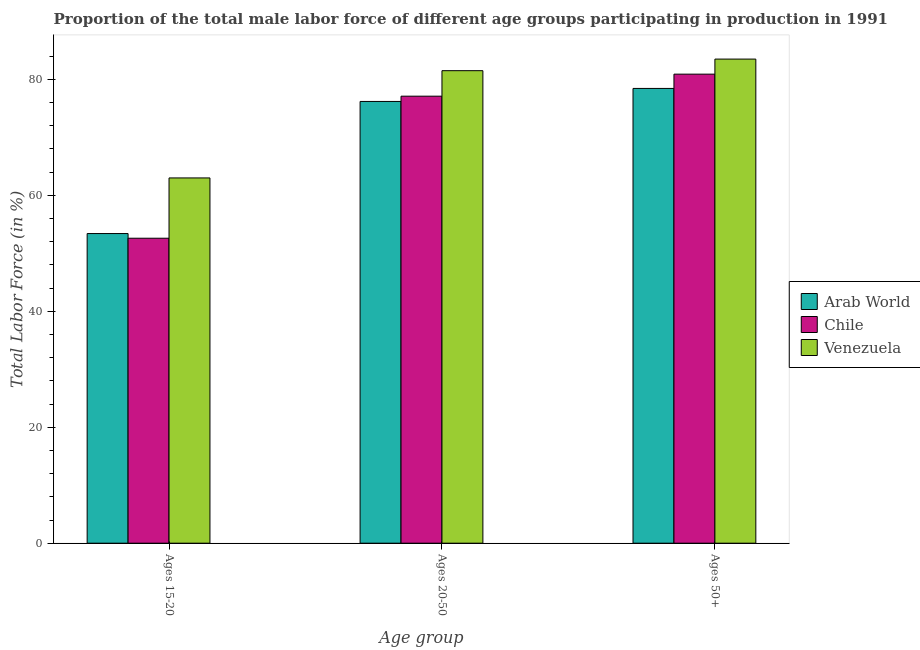How many different coloured bars are there?
Give a very brief answer. 3. What is the label of the 2nd group of bars from the left?
Offer a very short reply. Ages 20-50. What is the percentage of male labor force within the age group 15-20 in Chile?
Offer a very short reply. 52.6. Across all countries, what is the minimum percentage of male labor force within the age group 20-50?
Provide a succinct answer. 76.19. In which country was the percentage of male labor force within the age group 15-20 maximum?
Offer a terse response. Venezuela. In which country was the percentage of male labor force above age 50 minimum?
Give a very brief answer. Arab World. What is the total percentage of male labor force within the age group 20-50 in the graph?
Keep it short and to the point. 234.79. What is the difference between the percentage of male labor force above age 50 in Chile and that in Arab World?
Offer a very short reply. 2.46. What is the difference between the percentage of male labor force within the age group 20-50 in Venezuela and the percentage of male labor force within the age group 15-20 in Chile?
Provide a succinct answer. 28.9. What is the average percentage of male labor force within the age group 20-50 per country?
Offer a very short reply. 78.26. What is the difference between the percentage of male labor force within the age group 15-20 and percentage of male labor force above age 50 in Venezuela?
Offer a very short reply. -20.5. In how many countries, is the percentage of male labor force above age 50 greater than 24 %?
Ensure brevity in your answer.  3. What is the ratio of the percentage of male labor force within the age group 20-50 in Chile to that in Arab World?
Offer a terse response. 1.01. Is the difference between the percentage of male labor force above age 50 in Venezuela and Arab World greater than the difference between the percentage of male labor force within the age group 20-50 in Venezuela and Arab World?
Keep it short and to the point. No. What is the difference between the highest and the second highest percentage of male labor force within the age group 20-50?
Give a very brief answer. 4.4. What is the difference between the highest and the lowest percentage of male labor force within the age group 20-50?
Provide a short and direct response. 5.31. In how many countries, is the percentage of male labor force above age 50 greater than the average percentage of male labor force above age 50 taken over all countries?
Provide a short and direct response. 1. Is the sum of the percentage of male labor force within the age group 20-50 in Venezuela and Chile greater than the maximum percentage of male labor force within the age group 15-20 across all countries?
Your answer should be very brief. Yes. What does the 3rd bar from the right in Ages 20-50 represents?
Your response must be concise. Arab World. Is it the case that in every country, the sum of the percentage of male labor force within the age group 15-20 and percentage of male labor force within the age group 20-50 is greater than the percentage of male labor force above age 50?
Provide a succinct answer. Yes. Are all the bars in the graph horizontal?
Your answer should be compact. No. What is the difference between two consecutive major ticks on the Y-axis?
Give a very brief answer. 20. Does the graph contain any zero values?
Make the answer very short. No. What is the title of the graph?
Your response must be concise. Proportion of the total male labor force of different age groups participating in production in 1991. What is the label or title of the X-axis?
Offer a very short reply. Age group. What is the Total Labor Force (in %) in Arab World in Ages 15-20?
Offer a very short reply. 53.41. What is the Total Labor Force (in %) in Chile in Ages 15-20?
Your response must be concise. 52.6. What is the Total Labor Force (in %) in Arab World in Ages 20-50?
Provide a short and direct response. 76.19. What is the Total Labor Force (in %) in Chile in Ages 20-50?
Offer a very short reply. 77.1. What is the Total Labor Force (in %) of Venezuela in Ages 20-50?
Give a very brief answer. 81.5. What is the Total Labor Force (in %) of Arab World in Ages 50+?
Your answer should be very brief. 78.44. What is the Total Labor Force (in %) in Chile in Ages 50+?
Give a very brief answer. 80.9. What is the Total Labor Force (in %) of Venezuela in Ages 50+?
Offer a terse response. 83.5. Across all Age group, what is the maximum Total Labor Force (in %) of Arab World?
Provide a short and direct response. 78.44. Across all Age group, what is the maximum Total Labor Force (in %) of Chile?
Provide a succinct answer. 80.9. Across all Age group, what is the maximum Total Labor Force (in %) in Venezuela?
Offer a terse response. 83.5. Across all Age group, what is the minimum Total Labor Force (in %) of Arab World?
Provide a succinct answer. 53.41. Across all Age group, what is the minimum Total Labor Force (in %) in Chile?
Your answer should be very brief. 52.6. Across all Age group, what is the minimum Total Labor Force (in %) in Venezuela?
Your answer should be compact. 63. What is the total Total Labor Force (in %) of Arab World in the graph?
Give a very brief answer. 208.04. What is the total Total Labor Force (in %) in Chile in the graph?
Keep it short and to the point. 210.6. What is the total Total Labor Force (in %) of Venezuela in the graph?
Ensure brevity in your answer.  228. What is the difference between the Total Labor Force (in %) of Arab World in Ages 15-20 and that in Ages 20-50?
Make the answer very short. -22.78. What is the difference between the Total Labor Force (in %) in Chile in Ages 15-20 and that in Ages 20-50?
Your answer should be very brief. -24.5. What is the difference between the Total Labor Force (in %) of Venezuela in Ages 15-20 and that in Ages 20-50?
Provide a short and direct response. -18.5. What is the difference between the Total Labor Force (in %) in Arab World in Ages 15-20 and that in Ages 50+?
Ensure brevity in your answer.  -25.03. What is the difference between the Total Labor Force (in %) of Chile in Ages 15-20 and that in Ages 50+?
Provide a succinct answer. -28.3. What is the difference between the Total Labor Force (in %) of Venezuela in Ages 15-20 and that in Ages 50+?
Provide a short and direct response. -20.5. What is the difference between the Total Labor Force (in %) in Arab World in Ages 20-50 and that in Ages 50+?
Offer a very short reply. -2.25. What is the difference between the Total Labor Force (in %) in Arab World in Ages 15-20 and the Total Labor Force (in %) in Chile in Ages 20-50?
Provide a short and direct response. -23.69. What is the difference between the Total Labor Force (in %) in Arab World in Ages 15-20 and the Total Labor Force (in %) in Venezuela in Ages 20-50?
Your answer should be compact. -28.09. What is the difference between the Total Labor Force (in %) of Chile in Ages 15-20 and the Total Labor Force (in %) of Venezuela in Ages 20-50?
Your answer should be very brief. -28.9. What is the difference between the Total Labor Force (in %) of Arab World in Ages 15-20 and the Total Labor Force (in %) of Chile in Ages 50+?
Your answer should be compact. -27.49. What is the difference between the Total Labor Force (in %) of Arab World in Ages 15-20 and the Total Labor Force (in %) of Venezuela in Ages 50+?
Make the answer very short. -30.09. What is the difference between the Total Labor Force (in %) in Chile in Ages 15-20 and the Total Labor Force (in %) in Venezuela in Ages 50+?
Provide a short and direct response. -30.9. What is the difference between the Total Labor Force (in %) in Arab World in Ages 20-50 and the Total Labor Force (in %) in Chile in Ages 50+?
Make the answer very short. -4.71. What is the difference between the Total Labor Force (in %) of Arab World in Ages 20-50 and the Total Labor Force (in %) of Venezuela in Ages 50+?
Offer a terse response. -7.31. What is the difference between the Total Labor Force (in %) in Chile in Ages 20-50 and the Total Labor Force (in %) in Venezuela in Ages 50+?
Offer a terse response. -6.4. What is the average Total Labor Force (in %) of Arab World per Age group?
Make the answer very short. 69.35. What is the average Total Labor Force (in %) of Chile per Age group?
Offer a terse response. 70.2. What is the difference between the Total Labor Force (in %) in Arab World and Total Labor Force (in %) in Chile in Ages 15-20?
Your answer should be compact. 0.81. What is the difference between the Total Labor Force (in %) of Arab World and Total Labor Force (in %) of Venezuela in Ages 15-20?
Provide a short and direct response. -9.59. What is the difference between the Total Labor Force (in %) in Chile and Total Labor Force (in %) in Venezuela in Ages 15-20?
Provide a short and direct response. -10.4. What is the difference between the Total Labor Force (in %) in Arab World and Total Labor Force (in %) in Chile in Ages 20-50?
Provide a succinct answer. -0.91. What is the difference between the Total Labor Force (in %) of Arab World and Total Labor Force (in %) of Venezuela in Ages 20-50?
Offer a very short reply. -5.31. What is the difference between the Total Labor Force (in %) in Chile and Total Labor Force (in %) in Venezuela in Ages 20-50?
Your answer should be compact. -4.4. What is the difference between the Total Labor Force (in %) of Arab World and Total Labor Force (in %) of Chile in Ages 50+?
Your answer should be compact. -2.46. What is the difference between the Total Labor Force (in %) of Arab World and Total Labor Force (in %) of Venezuela in Ages 50+?
Your response must be concise. -5.06. What is the ratio of the Total Labor Force (in %) in Arab World in Ages 15-20 to that in Ages 20-50?
Your response must be concise. 0.7. What is the ratio of the Total Labor Force (in %) in Chile in Ages 15-20 to that in Ages 20-50?
Provide a succinct answer. 0.68. What is the ratio of the Total Labor Force (in %) in Venezuela in Ages 15-20 to that in Ages 20-50?
Ensure brevity in your answer.  0.77. What is the ratio of the Total Labor Force (in %) of Arab World in Ages 15-20 to that in Ages 50+?
Make the answer very short. 0.68. What is the ratio of the Total Labor Force (in %) of Chile in Ages 15-20 to that in Ages 50+?
Provide a short and direct response. 0.65. What is the ratio of the Total Labor Force (in %) of Venezuela in Ages 15-20 to that in Ages 50+?
Provide a succinct answer. 0.75. What is the ratio of the Total Labor Force (in %) in Arab World in Ages 20-50 to that in Ages 50+?
Your answer should be compact. 0.97. What is the ratio of the Total Labor Force (in %) of Chile in Ages 20-50 to that in Ages 50+?
Make the answer very short. 0.95. What is the difference between the highest and the second highest Total Labor Force (in %) in Arab World?
Offer a terse response. 2.25. What is the difference between the highest and the second highest Total Labor Force (in %) of Chile?
Your answer should be compact. 3.8. What is the difference between the highest and the second highest Total Labor Force (in %) in Venezuela?
Offer a very short reply. 2. What is the difference between the highest and the lowest Total Labor Force (in %) in Arab World?
Your answer should be very brief. 25.03. What is the difference between the highest and the lowest Total Labor Force (in %) of Chile?
Your answer should be compact. 28.3. 